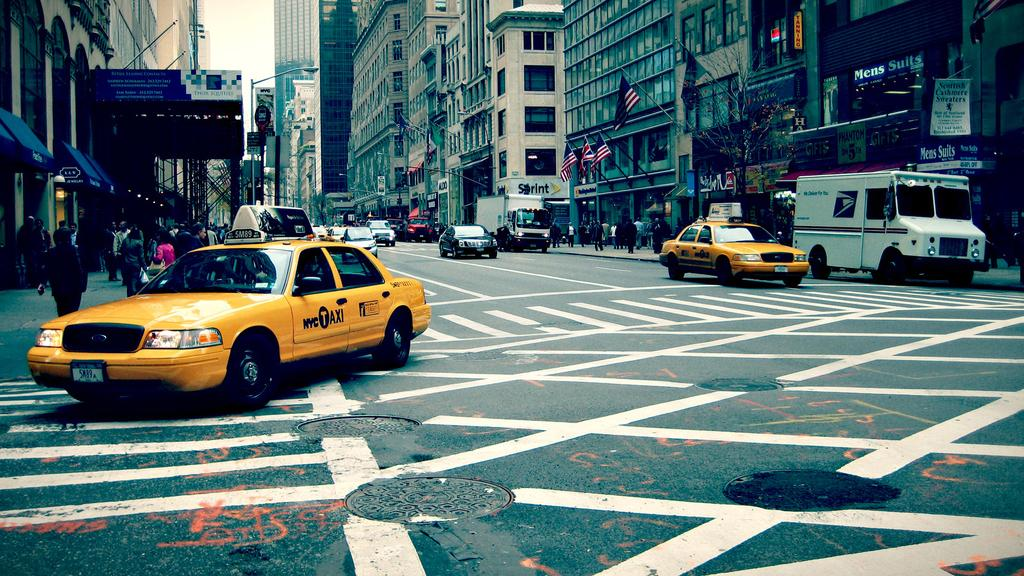What is happening on the road in the image? There are cars travelling on the road in the image. What type of vehicle is present in the image? There is a vehicle in the image. What decorative elements can be seen in the image? There are flags in the image. What type of structures are visible in the image? There are buildings in the image. What type of lighting is present in the image? There is a street light in the image. What part of the natural environment is visible in the image? The sky is visible in the image. What type of curve can be seen in the image? There is no curve visible in the image; it features cars travelling on a road, flags, buildings, a street light, and the sky. What type of band is performing in the image? There is no band present in the image; it features cars travelling on a road, flags, buildings, a street light, and the sky. 